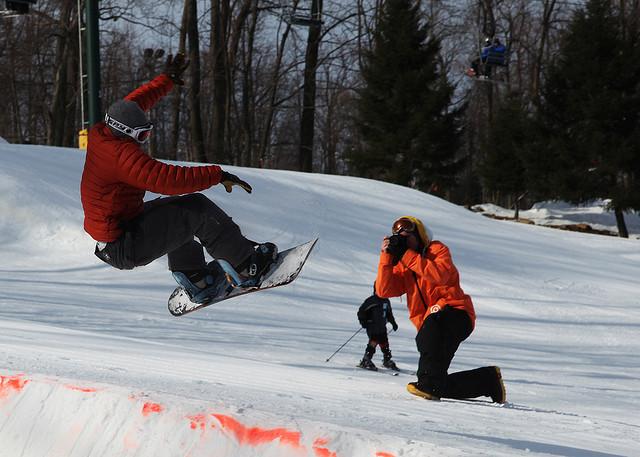Are there desirous trees in this photo?
Keep it brief. Yes. Why is the orange line on the surface?
Concise answer only. Paint. Is one of the people a photographer?
Quick response, please. Yes. Are they going to fall or land correctly?
Answer briefly. Land. How many people are on boards?
Concise answer only. 1. 